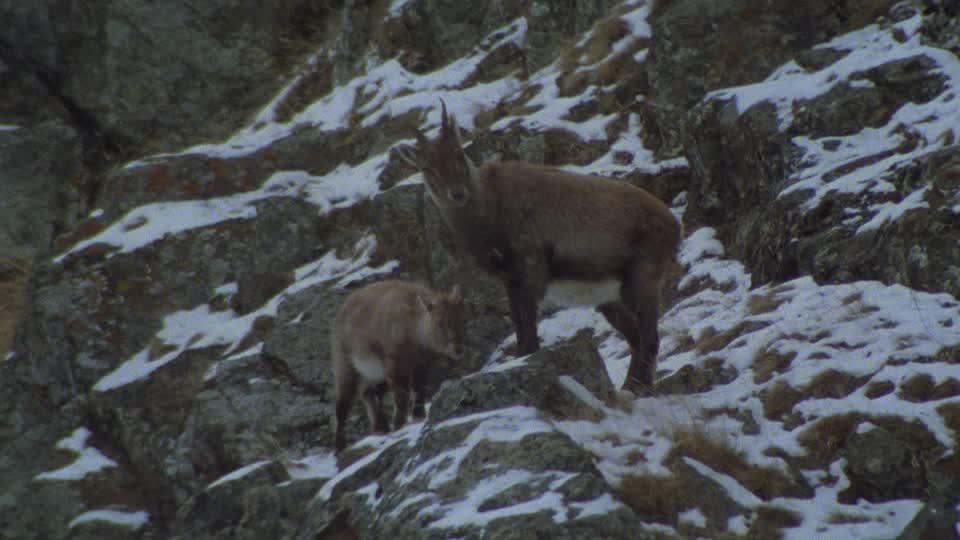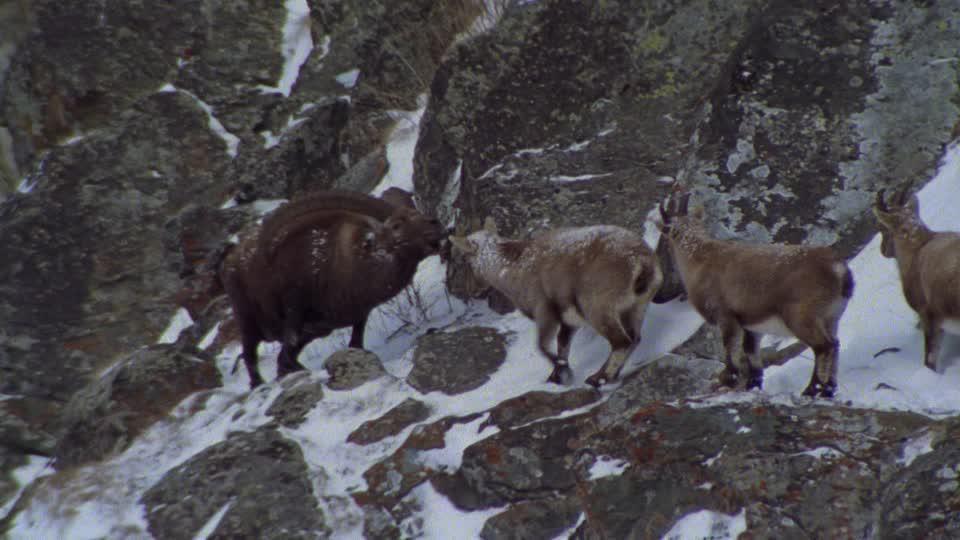The first image is the image on the left, the second image is the image on the right. For the images displayed, is the sentence "There are six mountain goats." factually correct? Answer yes or no. Yes. 